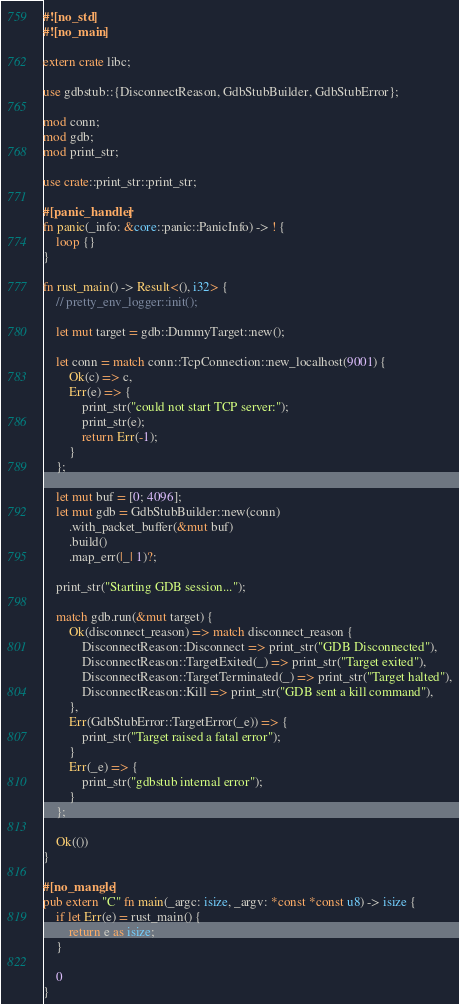<code> <loc_0><loc_0><loc_500><loc_500><_Rust_>#![no_std]
#![no_main]

extern crate libc;

use gdbstub::{DisconnectReason, GdbStubBuilder, GdbStubError};

mod conn;
mod gdb;
mod print_str;

use crate::print_str::print_str;

#[panic_handler]
fn panic(_info: &core::panic::PanicInfo) -> ! {
    loop {}
}

fn rust_main() -> Result<(), i32> {
    // pretty_env_logger::init();

    let mut target = gdb::DummyTarget::new();

    let conn = match conn::TcpConnection::new_localhost(9001) {
        Ok(c) => c,
        Err(e) => {
            print_str("could not start TCP server:");
            print_str(e);
            return Err(-1);
        }
    };

    let mut buf = [0; 4096];
    let mut gdb = GdbStubBuilder::new(conn)
        .with_packet_buffer(&mut buf)
        .build()
        .map_err(|_| 1)?;

    print_str("Starting GDB session...");

    match gdb.run(&mut target) {
        Ok(disconnect_reason) => match disconnect_reason {
            DisconnectReason::Disconnect => print_str("GDB Disconnected"),
            DisconnectReason::TargetExited(_) => print_str("Target exited"),
            DisconnectReason::TargetTerminated(_) => print_str("Target halted"),
            DisconnectReason::Kill => print_str("GDB sent a kill command"),
        },
        Err(GdbStubError::TargetError(_e)) => {
            print_str("Target raised a fatal error");
        }
        Err(_e) => {
            print_str("gdbstub internal error");
        }
    };

    Ok(())
}

#[no_mangle]
pub extern "C" fn main(_argc: isize, _argv: *const *const u8) -> isize {
    if let Err(e) = rust_main() {
        return e as isize;
    }

    0
}
</code> 